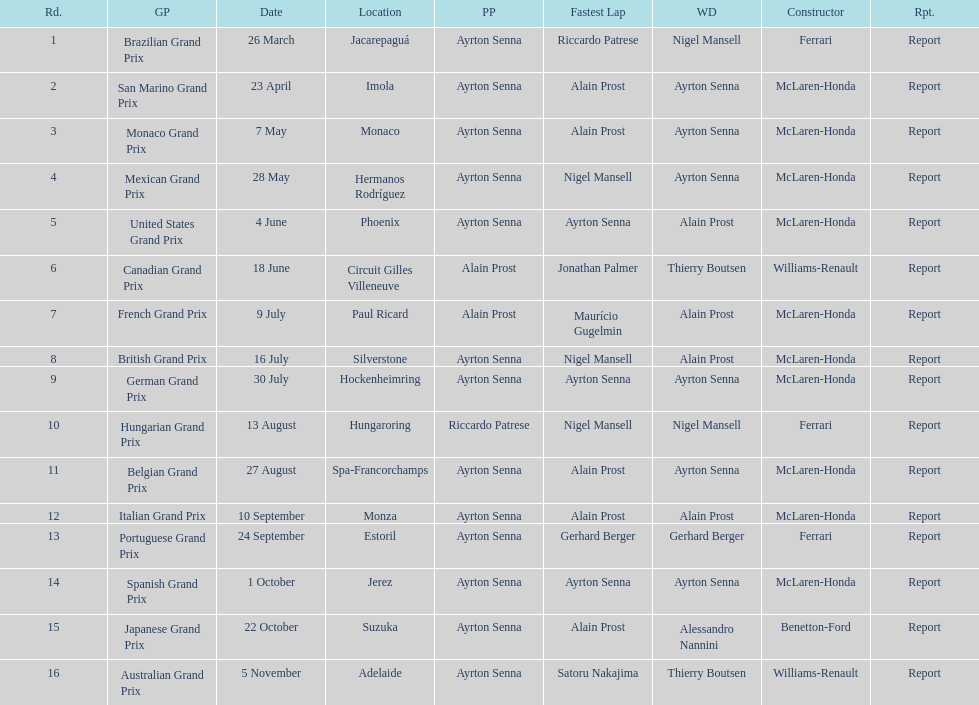How many races occurred before alain prost won a pole position? 5. 